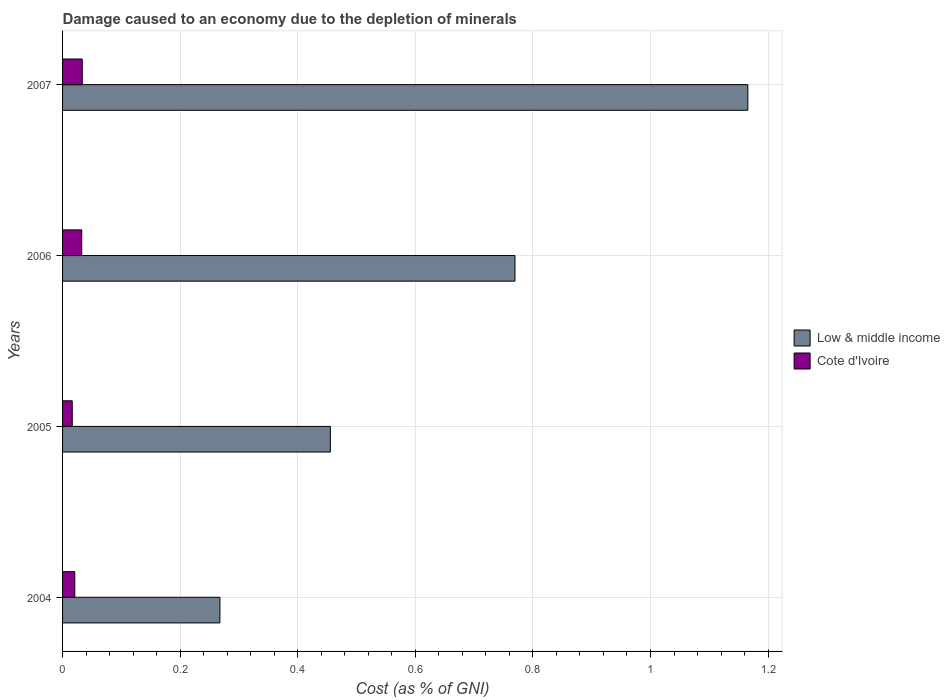How many groups of bars are there?
Your answer should be very brief. 4. Are the number of bars per tick equal to the number of legend labels?
Give a very brief answer. Yes. Are the number of bars on each tick of the Y-axis equal?
Ensure brevity in your answer.  Yes. How many bars are there on the 1st tick from the bottom?
Provide a short and direct response. 2. What is the label of the 4th group of bars from the top?
Make the answer very short. 2004. In how many cases, is the number of bars for a given year not equal to the number of legend labels?
Provide a succinct answer. 0. What is the cost of damage caused due to the depletion of minerals in Cote d'Ivoire in 2006?
Give a very brief answer. 0.03. Across all years, what is the maximum cost of damage caused due to the depletion of minerals in Low & middle income?
Offer a terse response. 1.17. Across all years, what is the minimum cost of damage caused due to the depletion of minerals in Low & middle income?
Your response must be concise. 0.27. In which year was the cost of damage caused due to the depletion of minerals in Low & middle income maximum?
Offer a very short reply. 2007. What is the total cost of damage caused due to the depletion of minerals in Cote d'Ivoire in the graph?
Give a very brief answer. 0.1. What is the difference between the cost of damage caused due to the depletion of minerals in Low & middle income in 2004 and that in 2005?
Ensure brevity in your answer.  -0.19. What is the difference between the cost of damage caused due to the depletion of minerals in Cote d'Ivoire in 2006 and the cost of damage caused due to the depletion of minerals in Low & middle income in 2007?
Give a very brief answer. -1.13. What is the average cost of damage caused due to the depletion of minerals in Cote d'Ivoire per year?
Make the answer very short. 0.03. In the year 2006, what is the difference between the cost of damage caused due to the depletion of minerals in Cote d'Ivoire and cost of damage caused due to the depletion of minerals in Low & middle income?
Keep it short and to the point. -0.74. In how many years, is the cost of damage caused due to the depletion of minerals in Low & middle income greater than 0.44 %?
Your response must be concise. 3. What is the ratio of the cost of damage caused due to the depletion of minerals in Low & middle income in 2005 to that in 2006?
Your answer should be very brief. 0.59. Is the cost of damage caused due to the depletion of minerals in Low & middle income in 2006 less than that in 2007?
Offer a very short reply. Yes. What is the difference between the highest and the second highest cost of damage caused due to the depletion of minerals in Low & middle income?
Provide a short and direct response. 0.4. What is the difference between the highest and the lowest cost of damage caused due to the depletion of minerals in Cote d'Ivoire?
Your answer should be compact. 0.02. In how many years, is the cost of damage caused due to the depletion of minerals in Low & middle income greater than the average cost of damage caused due to the depletion of minerals in Low & middle income taken over all years?
Keep it short and to the point. 2. What does the 2nd bar from the bottom in 2006 represents?
Your response must be concise. Cote d'Ivoire. How many bars are there?
Ensure brevity in your answer.  8. Are all the bars in the graph horizontal?
Your answer should be compact. Yes. How many years are there in the graph?
Offer a terse response. 4. What is the difference between two consecutive major ticks on the X-axis?
Provide a short and direct response. 0.2. Does the graph contain any zero values?
Give a very brief answer. No. Does the graph contain grids?
Provide a short and direct response. Yes. Where does the legend appear in the graph?
Provide a succinct answer. Center right. How many legend labels are there?
Keep it short and to the point. 2. How are the legend labels stacked?
Ensure brevity in your answer.  Vertical. What is the title of the graph?
Your response must be concise. Damage caused to an economy due to the depletion of minerals. Does "United Arab Emirates" appear as one of the legend labels in the graph?
Give a very brief answer. No. What is the label or title of the X-axis?
Your answer should be very brief. Cost (as % of GNI). What is the Cost (as % of GNI) in Low & middle income in 2004?
Give a very brief answer. 0.27. What is the Cost (as % of GNI) in Cote d'Ivoire in 2004?
Your answer should be very brief. 0.02. What is the Cost (as % of GNI) of Low & middle income in 2005?
Your answer should be very brief. 0.46. What is the Cost (as % of GNI) of Cote d'Ivoire in 2005?
Your answer should be very brief. 0.02. What is the Cost (as % of GNI) in Low & middle income in 2006?
Provide a short and direct response. 0.77. What is the Cost (as % of GNI) in Cote d'Ivoire in 2006?
Provide a short and direct response. 0.03. What is the Cost (as % of GNI) in Low & middle income in 2007?
Make the answer very short. 1.17. What is the Cost (as % of GNI) of Cote d'Ivoire in 2007?
Offer a terse response. 0.03. Across all years, what is the maximum Cost (as % of GNI) in Low & middle income?
Your response must be concise. 1.17. Across all years, what is the maximum Cost (as % of GNI) of Cote d'Ivoire?
Make the answer very short. 0.03. Across all years, what is the minimum Cost (as % of GNI) of Low & middle income?
Give a very brief answer. 0.27. Across all years, what is the minimum Cost (as % of GNI) in Cote d'Ivoire?
Your answer should be compact. 0.02. What is the total Cost (as % of GNI) in Low & middle income in the graph?
Ensure brevity in your answer.  2.66. What is the total Cost (as % of GNI) in Cote d'Ivoire in the graph?
Keep it short and to the point. 0.1. What is the difference between the Cost (as % of GNI) in Low & middle income in 2004 and that in 2005?
Your response must be concise. -0.19. What is the difference between the Cost (as % of GNI) of Cote d'Ivoire in 2004 and that in 2005?
Keep it short and to the point. 0. What is the difference between the Cost (as % of GNI) in Low & middle income in 2004 and that in 2006?
Ensure brevity in your answer.  -0.5. What is the difference between the Cost (as % of GNI) of Cote d'Ivoire in 2004 and that in 2006?
Keep it short and to the point. -0.01. What is the difference between the Cost (as % of GNI) in Low & middle income in 2004 and that in 2007?
Your answer should be very brief. -0.9. What is the difference between the Cost (as % of GNI) of Cote d'Ivoire in 2004 and that in 2007?
Your response must be concise. -0.01. What is the difference between the Cost (as % of GNI) of Low & middle income in 2005 and that in 2006?
Keep it short and to the point. -0.31. What is the difference between the Cost (as % of GNI) of Cote d'Ivoire in 2005 and that in 2006?
Make the answer very short. -0.02. What is the difference between the Cost (as % of GNI) of Low & middle income in 2005 and that in 2007?
Ensure brevity in your answer.  -0.71. What is the difference between the Cost (as % of GNI) in Cote d'Ivoire in 2005 and that in 2007?
Provide a succinct answer. -0.02. What is the difference between the Cost (as % of GNI) in Low & middle income in 2006 and that in 2007?
Give a very brief answer. -0.4. What is the difference between the Cost (as % of GNI) of Cote d'Ivoire in 2006 and that in 2007?
Your response must be concise. -0. What is the difference between the Cost (as % of GNI) in Low & middle income in 2004 and the Cost (as % of GNI) in Cote d'Ivoire in 2005?
Your response must be concise. 0.25. What is the difference between the Cost (as % of GNI) of Low & middle income in 2004 and the Cost (as % of GNI) of Cote d'Ivoire in 2006?
Give a very brief answer. 0.23. What is the difference between the Cost (as % of GNI) of Low & middle income in 2004 and the Cost (as % of GNI) of Cote d'Ivoire in 2007?
Provide a short and direct response. 0.23. What is the difference between the Cost (as % of GNI) in Low & middle income in 2005 and the Cost (as % of GNI) in Cote d'Ivoire in 2006?
Your answer should be compact. 0.42. What is the difference between the Cost (as % of GNI) in Low & middle income in 2005 and the Cost (as % of GNI) in Cote d'Ivoire in 2007?
Offer a very short reply. 0.42. What is the difference between the Cost (as % of GNI) of Low & middle income in 2006 and the Cost (as % of GNI) of Cote d'Ivoire in 2007?
Make the answer very short. 0.74. What is the average Cost (as % of GNI) in Low & middle income per year?
Make the answer very short. 0.66. What is the average Cost (as % of GNI) in Cote d'Ivoire per year?
Provide a succinct answer. 0.03. In the year 2004, what is the difference between the Cost (as % of GNI) of Low & middle income and Cost (as % of GNI) of Cote d'Ivoire?
Keep it short and to the point. 0.25. In the year 2005, what is the difference between the Cost (as % of GNI) in Low & middle income and Cost (as % of GNI) in Cote d'Ivoire?
Ensure brevity in your answer.  0.44. In the year 2006, what is the difference between the Cost (as % of GNI) of Low & middle income and Cost (as % of GNI) of Cote d'Ivoire?
Offer a very short reply. 0.74. In the year 2007, what is the difference between the Cost (as % of GNI) of Low & middle income and Cost (as % of GNI) of Cote d'Ivoire?
Provide a short and direct response. 1.13. What is the ratio of the Cost (as % of GNI) in Low & middle income in 2004 to that in 2005?
Offer a terse response. 0.59. What is the ratio of the Cost (as % of GNI) in Cote d'Ivoire in 2004 to that in 2005?
Make the answer very short. 1.26. What is the ratio of the Cost (as % of GNI) in Low & middle income in 2004 to that in 2006?
Your answer should be compact. 0.35. What is the ratio of the Cost (as % of GNI) in Cote d'Ivoire in 2004 to that in 2006?
Ensure brevity in your answer.  0.64. What is the ratio of the Cost (as % of GNI) of Low & middle income in 2004 to that in 2007?
Keep it short and to the point. 0.23. What is the ratio of the Cost (as % of GNI) in Cote d'Ivoire in 2004 to that in 2007?
Your answer should be compact. 0.62. What is the ratio of the Cost (as % of GNI) of Low & middle income in 2005 to that in 2006?
Give a very brief answer. 0.59. What is the ratio of the Cost (as % of GNI) in Cote d'Ivoire in 2005 to that in 2006?
Provide a succinct answer. 0.51. What is the ratio of the Cost (as % of GNI) of Low & middle income in 2005 to that in 2007?
Your answer should be compact. 0.39. What is the ratio of the Cost (as % of GNI) of Cote d'Ivoire in 2005 to that in 2007?
Offer a very short reply. 0.49. What is the ratio of the Cost (as % of GNI) in Low & middle income in 2006 to that in 2007?
Give a very brief answer. 0.66. What is the ratio of the Cost (as % of GNI) of Cote d'Ivoire in 2006 to that in 2007?
Offer a very short reply. 0.97. What is the difference between the highest and the second highest Cost (as % of GNI) in Low & middle income?
Give a very brief answer. 0.4. What is the difference between the highest and the second highest Cost (as % of GNI) of Cote d'Ivoire?
Provide a short and direct response. 0. What is the difference between the highest and the lowest Cost (as % of GNI) of Low & middle income?
Your response must be concise. 0.9. What is the difference between the highest and the lowest Cost (as % of GNI) of Cote d'Ivoire?
Offer a very short reply. 0.02. 